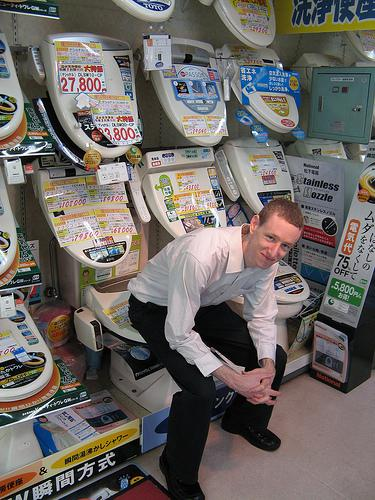Question: what are the items being sold here?
Choices:
A. Toilet.
B. Bidet.
C. Sink.
D. Mirror.
Answer with the letter. Answer: B Question: what is the color of the man's hair?
Choices:
A. Blonde.
B. Brunette.
C. White.
D. Red.
Answer with the letter. Answer: B Question: what is the man doing in the picture?
Choices:
A. Sitting on bidet.
B. Sitting on a toilet.
C. Sitting on the edge of the tub.
D. Sitting on the vanity.
Answer with the letter. Answer: A Question: where is the picture taken?
Choices:
A. Bidet store.
B. Grocery store.
C. Lighting store.
D. Pet store.
Answer with the letter. Answer: A 